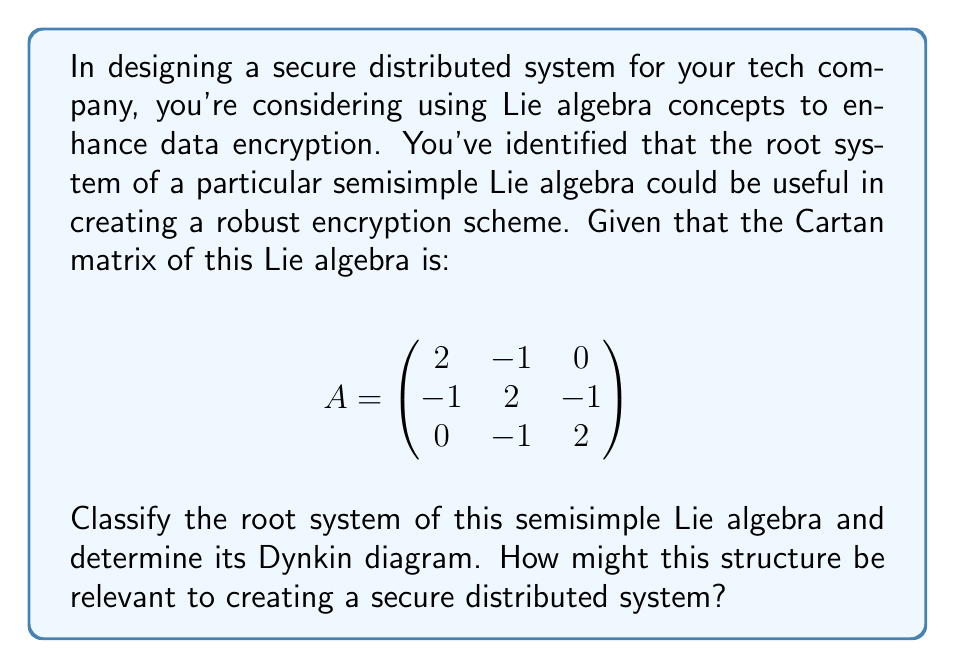Teach me how to tackle this problem. To classify the root system and determine the Dynkin diagram, we'll follow these steps:

1) First, we need to recognize the Cartan matrix. This matrix is symmetric and has 2's on the diagonal, which is characteristic of simply-laced Lie algebras (types A, D, E).

2) The off-diagonal elements are either 0 or -1, which confirms it's a simply-laced system.

3) The pattern of the matrix matches that of the $A_3$ Lie algebra, which corresponds to the special linear group $SL(4, \mathbb{C})$.

4) To construct the Dynkin diagram:
   - Each row/column of the Cartan matrix represents a simple root.
   - We draw a node for each simple root.
   - We connect nodes i and j with a single line if $A_{ij} = A_{ji} = -1$.
   - No connection is made if $A_{ij} = A_{ji} = 0$.

5) The resulting Dynkin diagram is:

[asy]
unitsize(1cm);
dot((0,0)); dot((1,0)); dot((2,0));
draw((0,0)--(2,0));
label("$\alpha_1$", (0,-0.5));
label("$\alpha_2$", (1,-0.5));
label("$\alpha_3$", (2,-0.5));
[/asy]

This confirms that the root system is indeed of type $A_3$.

Relevance to secure distributed systems:

a) The structure of $A_3$ provides a natural way to decompose data into three interconnected parts, which could be useful for data sharding in distributed systems.

b) The symmetry of the root system could be leveraged to create balanced encryption algorithms that distribute computational load evenly across system nodes.

c) The three-node structure of $A_3$ aligns well with the concept of three-factor authentication, potentially inspiring novel secure access protocols.

d) The properties of the special linear group $SL(4, \mathbb{C})$ associated with $A_3$ could be used to design linear transformations for data obfuscation in transit or storage.

e) The root system's structure could inform the design of network topologies that are inherently resistant to certain types of attacks or failures.
Answer: The root system is classified as type $A_3$, with the Dynkin diagram consisting of three nodes connected in a line. This structure, associated with the special linear group $SL(4, \mathbb{C})$, offers potential applications in data sharding, balanced encryption, multi-factor authentication, data obfuscation, and resilient network design for secure distributed systems. 